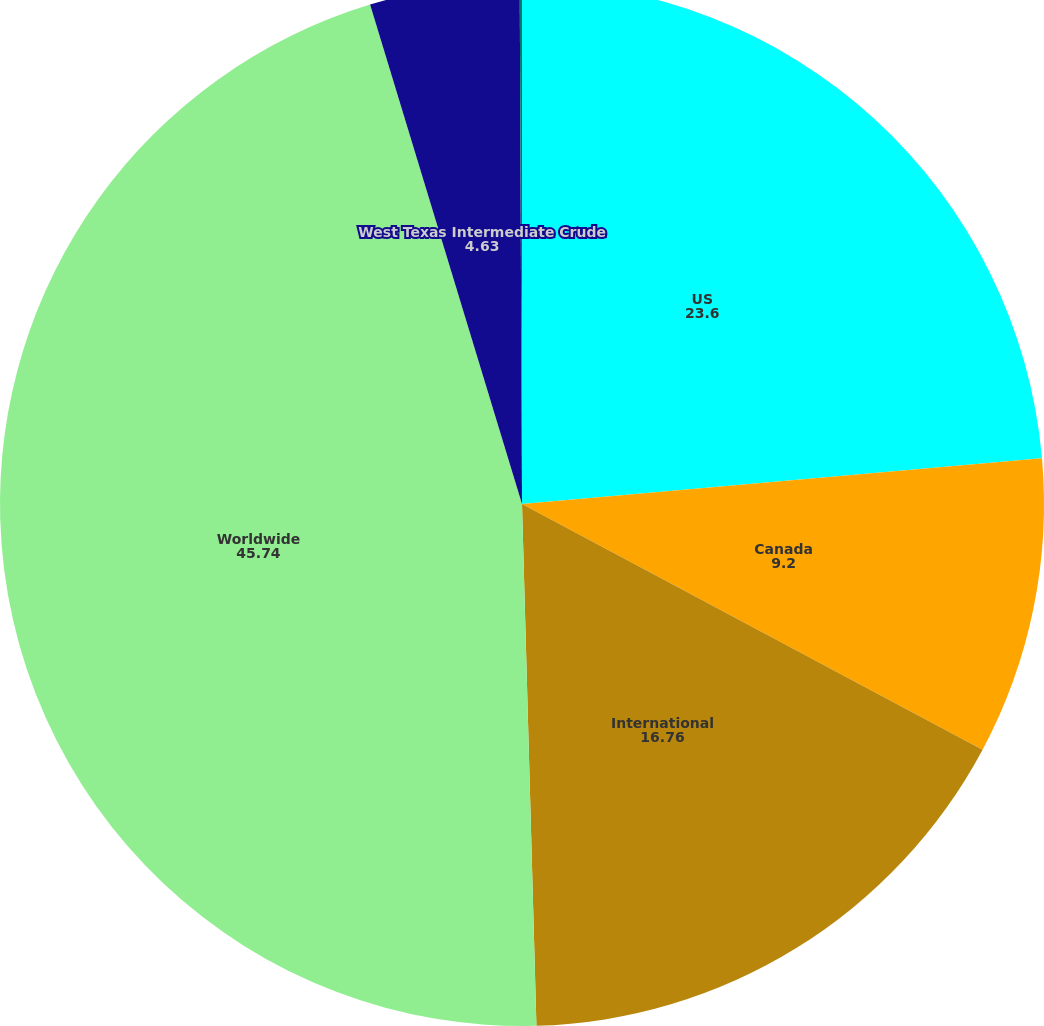<chart> <loc_0><loc_0><loc_500><loc_500><pie_chart><fcel>US<fcel>Canada<fcel>International<fcel>Worldwide<fcel>West Texas Intermediate Crude<fcel>Natural Gas Prices (/mmbtu)<nl><fcel>23.6%<fcel>9.2%<fcel>16.76%<fcel>45.74%<fcel>4.63%<fcel>0.07%<nl></chart> 